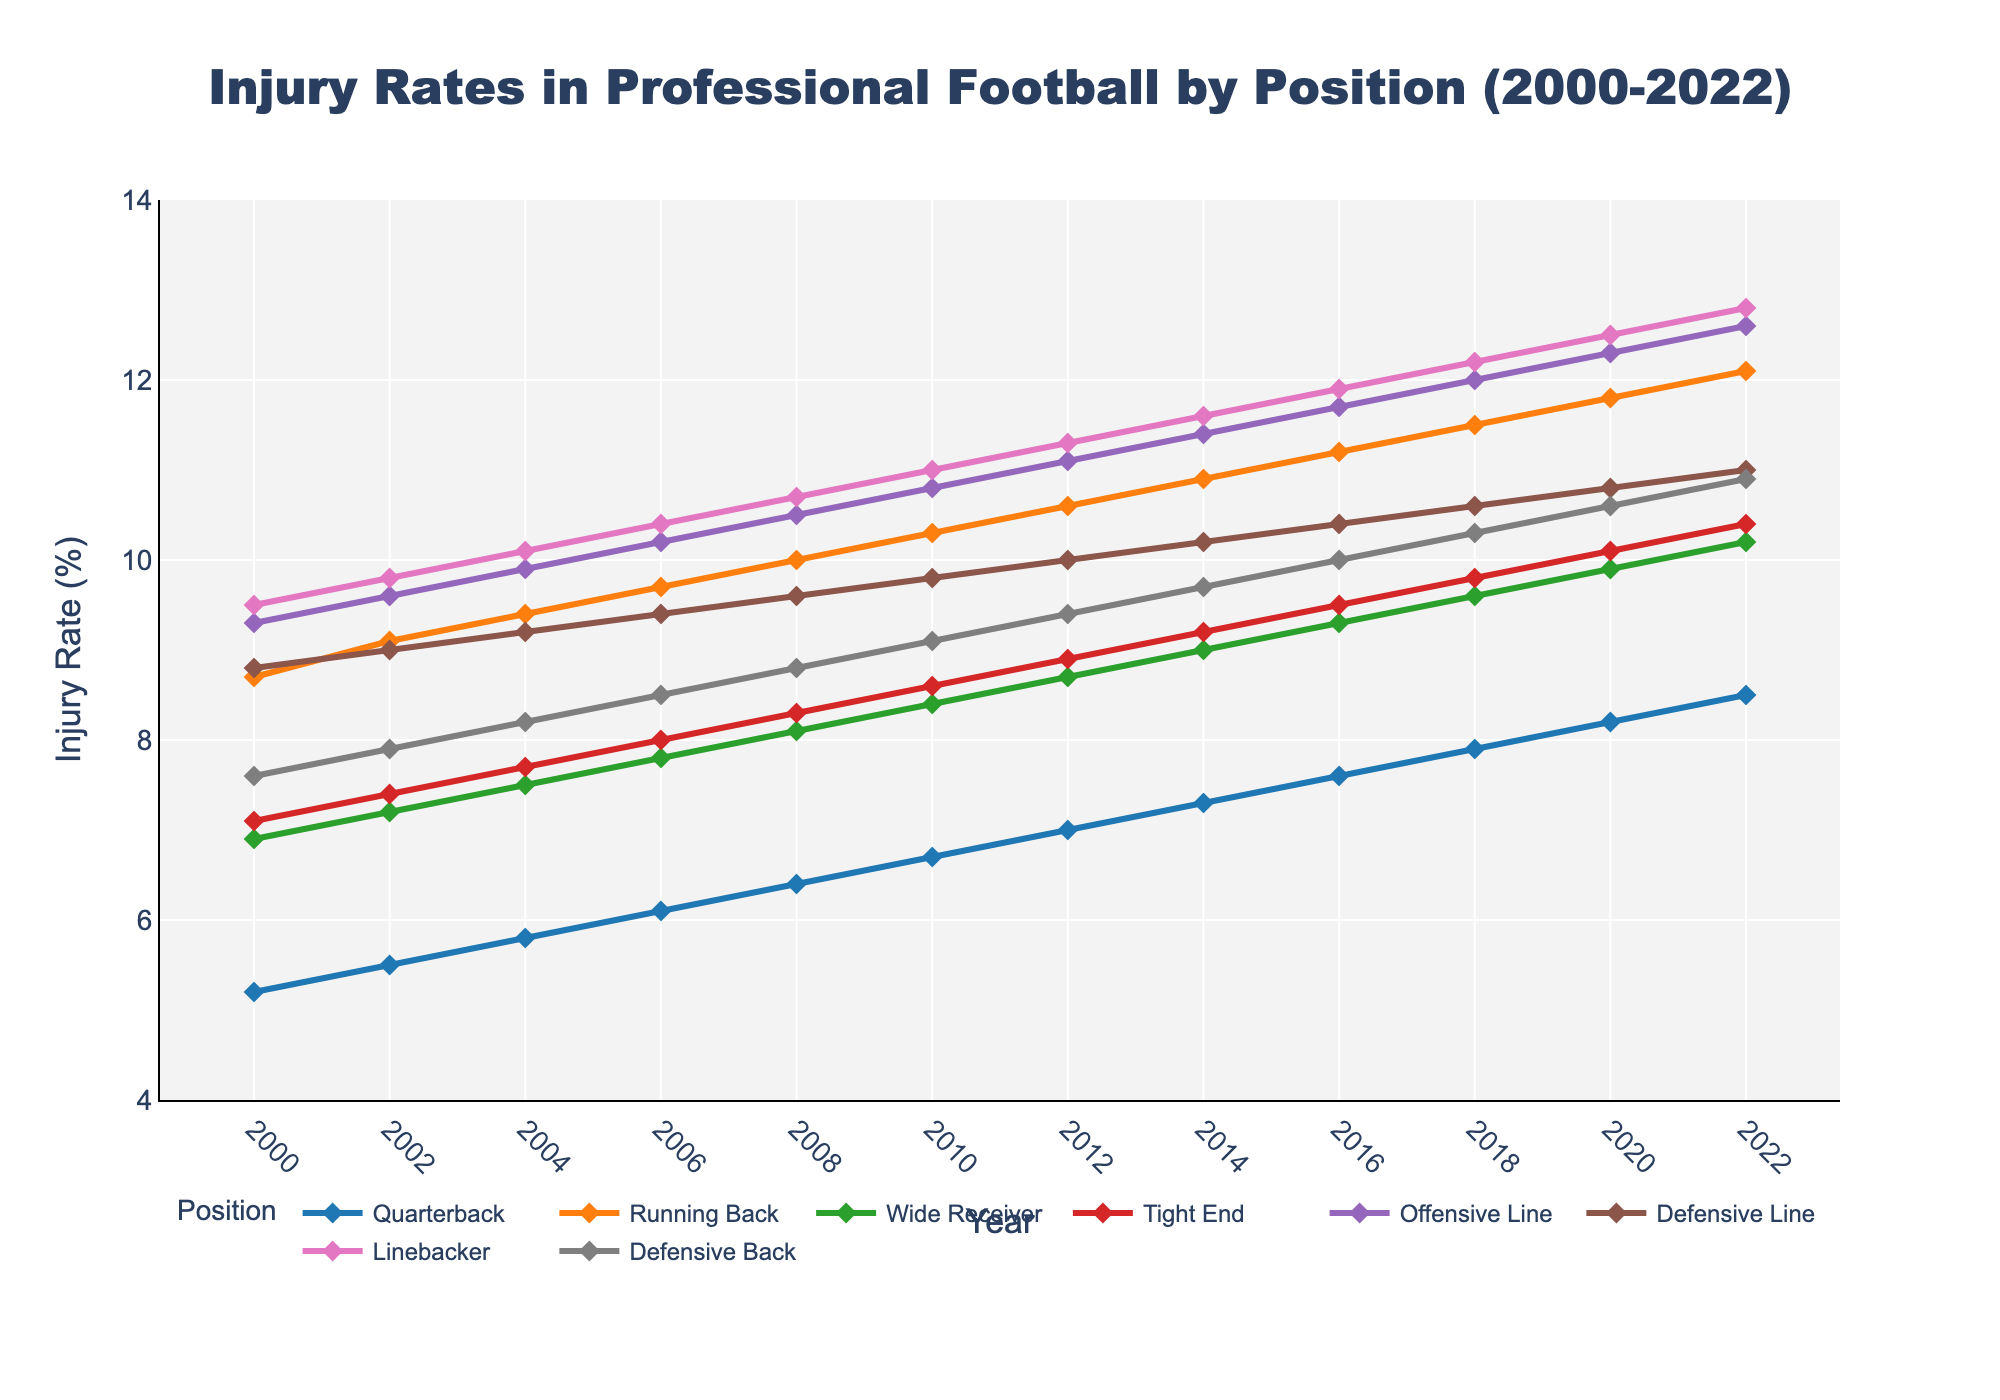What position had the lowest injury rate in 2000? Look at the data for the year 2000 and identify the position with the smallest value. In 2000, the Quarterback had the lowest injury rate of 5.2%.
Answer: Quarterback Which position saw the greatest increase in injury rate from 2000 to 2022? Calculate the difference in injury rates for each position between 2000 and 2022. Compare these differences to identify the position with the greatest increase. The Offensive Line increased from 9.3% to 12.6%, which is the largest increase of 3.3%.
Answer: Offensive Line What is the average injury rate of the Wide Receiver position from 2000 to 2022? Sum all injury rates of the Wide Receiver from each year and divide by the number of years. The average is calculated as (6.9+7.2+7.5+7.8+8.1+8.4+8.7+9.0+9.3+9.6+9.9+10.2)/12 = 8.425%.
Answer: 8.43% Between 2000 and 2010, which position had the most consistent (least variable) injury rate? Check for the position with the smallest range between the maximum and minimum values from 2000 to 2010. The Quarterback position ranges from 5.2 to 6.7, resulting in a range of 1.5, making it the most consistent.
Answer: Quarterback In what year did the Linebacker position exceed an injury rate of 10%? Identify when the Linebacker position's injury rate first meets or exceeds 10%. It first happened in 2004 with an injury rate of 10.1%.
Answer: 2004 What was the approximate overall trend of injury rates for the Defensive Back position from 2000 to 2022? Assess the data values over the entire period. The injury rate for the Defensive Back position started at 7.6% in 2000 and ended at 10.9% in 2022, showing an overall increasing trend.
Answer: Increasing Which two positions had injury rates that were closest to each other in 2006? Look at the injury rates for 2006 and compare to find the smallest difference. Tight End and Defensive Back had 8.0% and 8.5%, respectively, with a difference of 0.5%.
Answer: Tight End and Defensive Back What is the difference in injury rate between the highest injury rate position and the lowest injury rate position in 2020? Identify the highest and lowest injury rates in 2020, and compute their difference. Running Back is highest at 11.8% and Quarterback is lowest at 8.2%, resulting in a difference of 3.6%.
Answer: 3.6% Which position has shown the most general upward trend throughout the years? Evaluate the trends for each position by checking the overall increase from the initial to the final year. Quarterback shows a consistent upward trend from 5.2% to 8.5% compared to other positions where the trend is also upward but not as consistent.
Answer: Quarterback 